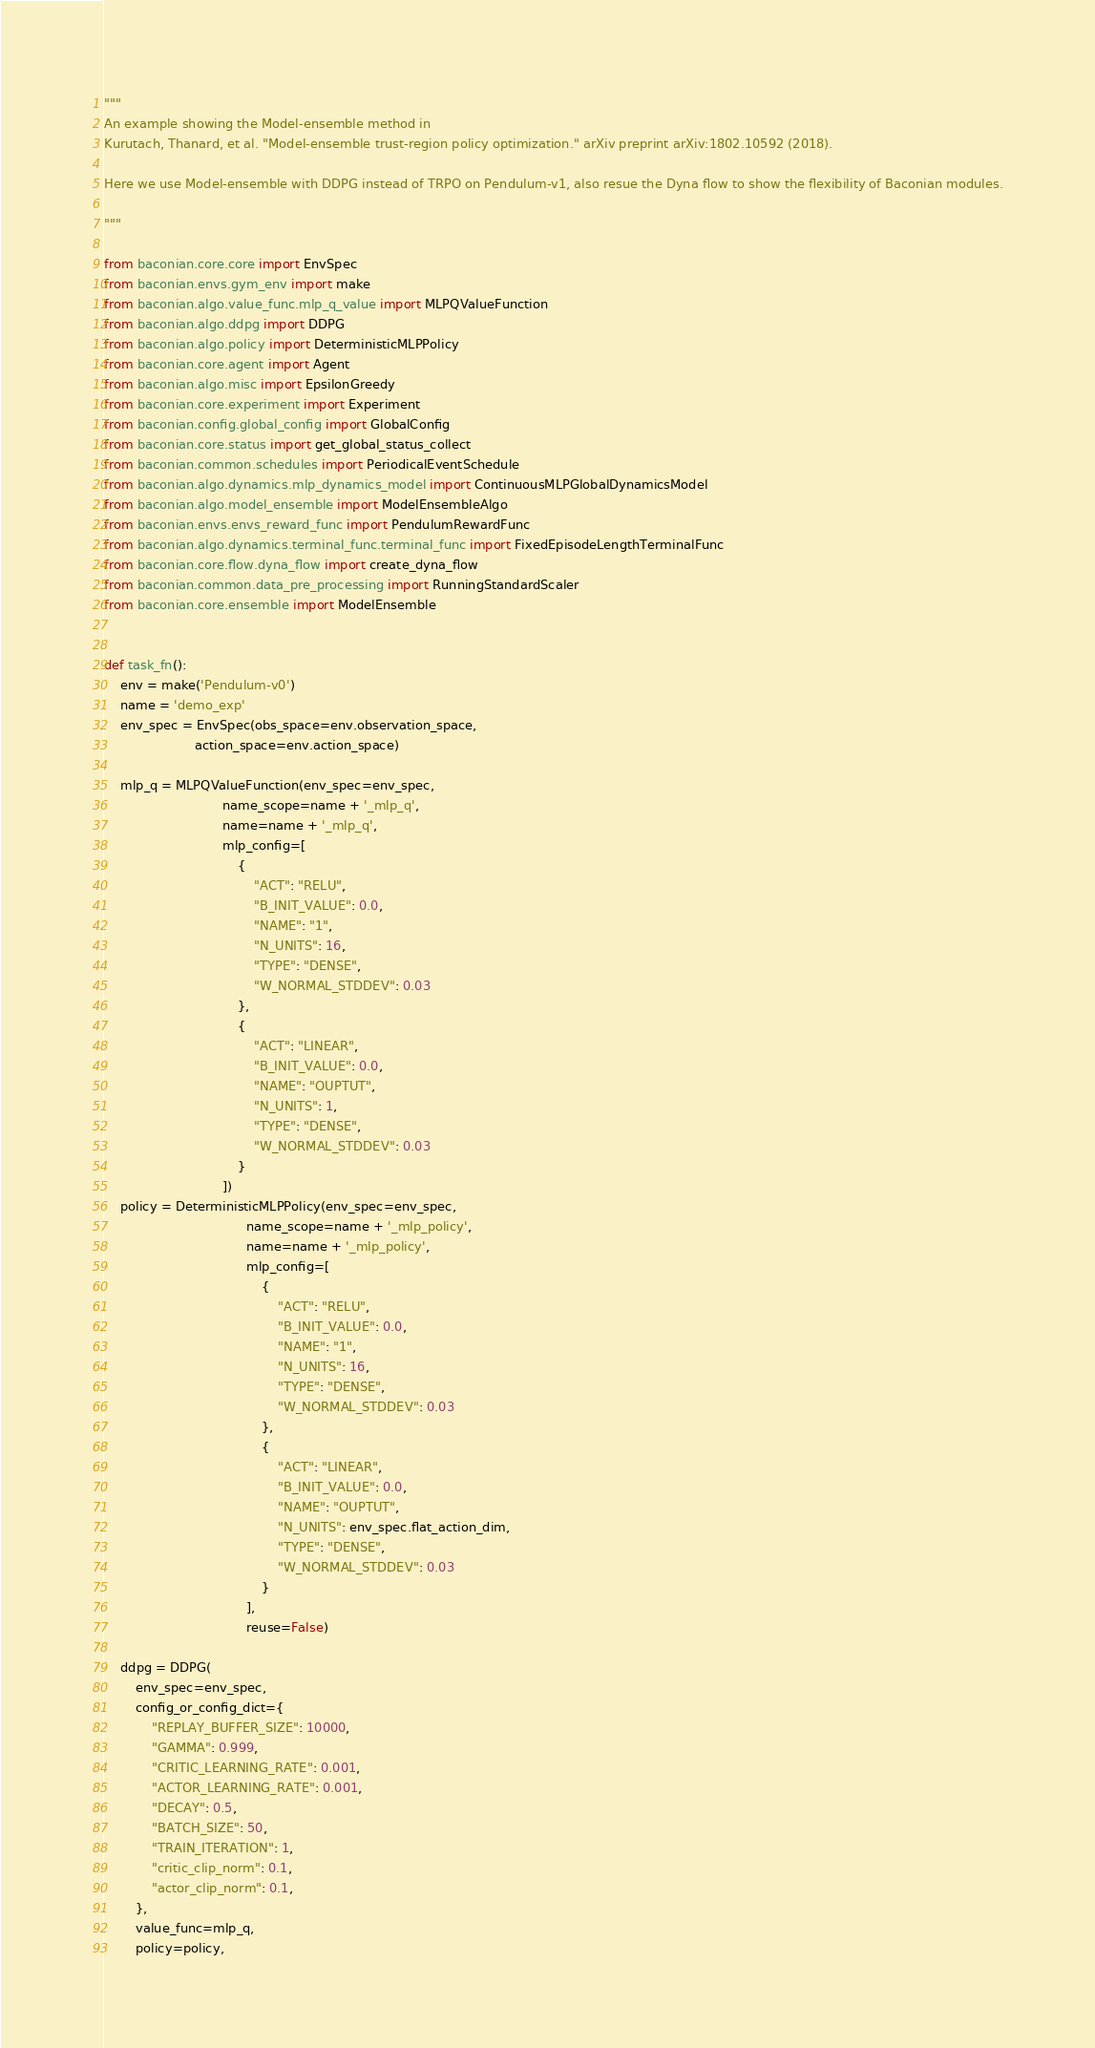Convert code to text. <code><loc_0><loc_0><loc_500><loc_500><_Python_>"""
An example showing the Model-ensemble method in
Kurutach, Thanard, et al. "Model-ensemble trust-region policy optimization." arXiv preprint arXiv:1802.10592 (2018).

Here we use Model-ensemble with DDPG instead of TRPO on Pendulum-v1, also resue the Dyna flow to show the flexibility of Baconian modules.

"""

from baconian.core.core import EnvSpec
from baconian.envs.gym_env import make
from baconian.algo.value_func.mlp_q_value import MLPQValueFunction
from baconian.algo.ddpg import DDPG
from baconian.algo.policy import DeterministicMLPPolicy
from baconian.core.agent import Agent
from baconian.algo.misc import EpsilonGreedy
from baconian.core.experiment import Experiment
from baconian.config.global_config import GlobalConfig
from baconian.core.status import get_global_status_collect
from baconian.common.schedules import PeriodicalEventSchedule
from baconian.algo.dynamics.mlp_dynamics_model import ContinuousMLPGlobalDynamicsModel
from baconian.algo.model_ensemble import ModelEnsembleAlgo
from baconian.envs.envs_reward_func import PendulumRewardFunc
from baconian.algo.dynamics.terminal_func.terminal_func import FixedEpisodeLengthTerminalFunc
from baconian.core.flow.dyna_flow import create_dyna_flow
from baconian.common.data_pre_processing import RunningStandardScaler
from baconian.core.ensemble import ModelEnsemble


def task_fn():
    env = make('Pendulum-v0')
    name = 'demo_exp'
    env_spec = EnvSpec(obs_space=env.observation_space,
                       action_space=env.action_space)

    mlp_q = MLPQValueFunction(env_spec=env_spec,
                              name_scope=name + '_mlp_q',
                              name=name + '_mlp_q',
                              mlp_config=[
                                  {
                                      "ACT": "RELU",
                                      "B_INIT_VALUE": 0.0,
                                      "NAME": "1",
                                      "N_UNITS": 16,
                                      "TYPE": "DENSE",
                                      "W_NORMAL_STDDEV": 0.03
                                  },
                                  {
                                      "ACT": "LINEAR",
                                      "B_INIT_VALUE": 0.0,
                                      "NAME": "OUPTUT",
                                      "N_UNITS": 1,
                                      "TYPE": "DENSE",
                                      "W_NORMAL_STDDEV": 0.03
                                  }
                              ])
    policy = DeterministicMLPPolicy(env_spec=env_spec,
                                    name_scope=name + '_mlp_policy',
                                    name=name + '_mlp_policy',
                                    mlp_config=[
                                        {
                                            "ACT": "RELU",
                                            "B_INIT_VALUE": 0.0,
                                            "NAME": "1",
                                            "N_UNITS": 16,
                                            "TYPE": "DENSE",
                                            "W_NORMAL_STDDEV": 0.03
                                        },
                                        {
                                            "ACT": "LINEAR",
                                            "B_INIT_VALUE": 0.0,
                                            "NAME": "OUPTUT",
                                            "N_UNITS": env_spec.flat_action_dim,
                                            "TYPE": "DENSE",
                                            "W_NORMAL_STDDEV": 0.03
                                        }
                                    ],
                                    reuse=False)

    ddpg = DDPG(
        env_spec=env_spec,
        config_or_config_dict={
            "REPLAY_BUFFER_SIZE": 10000,
            "GAMMA": 0.999,
            "CRITIC_LEARNING_RATE": 0.001,
            "ACTOR_LEARNING_RATE": 0.001,
            "DECAY": 0.5,
            "BATCH_SIZE": 50,
            "TRAIN_ITERATION": 1,
            "critic_clip_norm": 0.1,
            "actor_clip_norm": 0.1,
        },
        value_func=mlp_q,
        policy=policy,</code> 